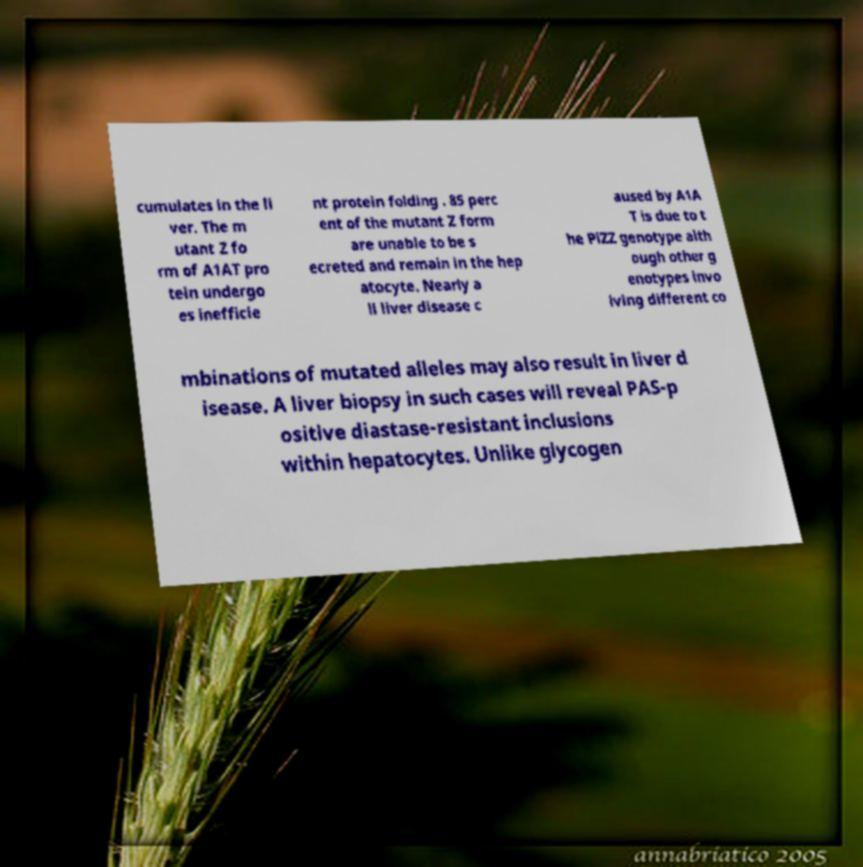Please read and relay the text visible in this image. What does it say? cumulates in the li ver. The m utant Z fo rm of A1AT pro tein undergo es inefficie nt protein folding . 85 perc ent of the mutant Z form are unable to be s ecreted and remain in the hep atocyte. Nearly a ll liver disease c aused by A1A T is due to t he PiZZ genotype alth ough other g enotypes invo lving different co mbinations of mutated alleles may also result in liver d isease. A liver biopsy in such cases will reveal PAS-p ositive diastase-resistant inclusions within hepatocytes. Unlike glycogen 